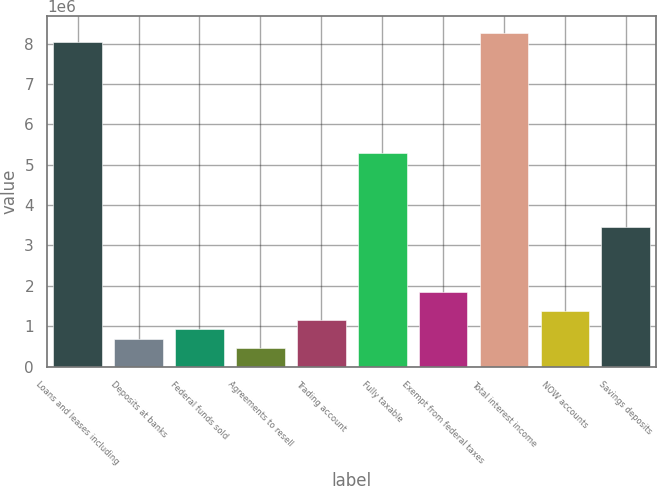Convert chart to OTSL. <chart><loc_0><loc_0><loc_500><loc_500><bar_chart><fcel>Loans and leases including<fcel>Deposits at banks<fcel>Federal funds sold<fcel>Agreements to resell<fcel>Trading account<fcel>Fully taxable<fcel>Exempt from federal taxes<fcel>Total interest income<fcel>NOW accounts<fcel>Savings deposits<nl><fcel>8.04555e+06<fcel>689624<fcel>919496<fcel>459751<fcel>1.14937e+06<fcel>5.28708e+06<fcel>1.83899e+06<fcel>8.27542e+06<fcel>1.37924e+06<fcel>3.4481e+06<nl></chart> 